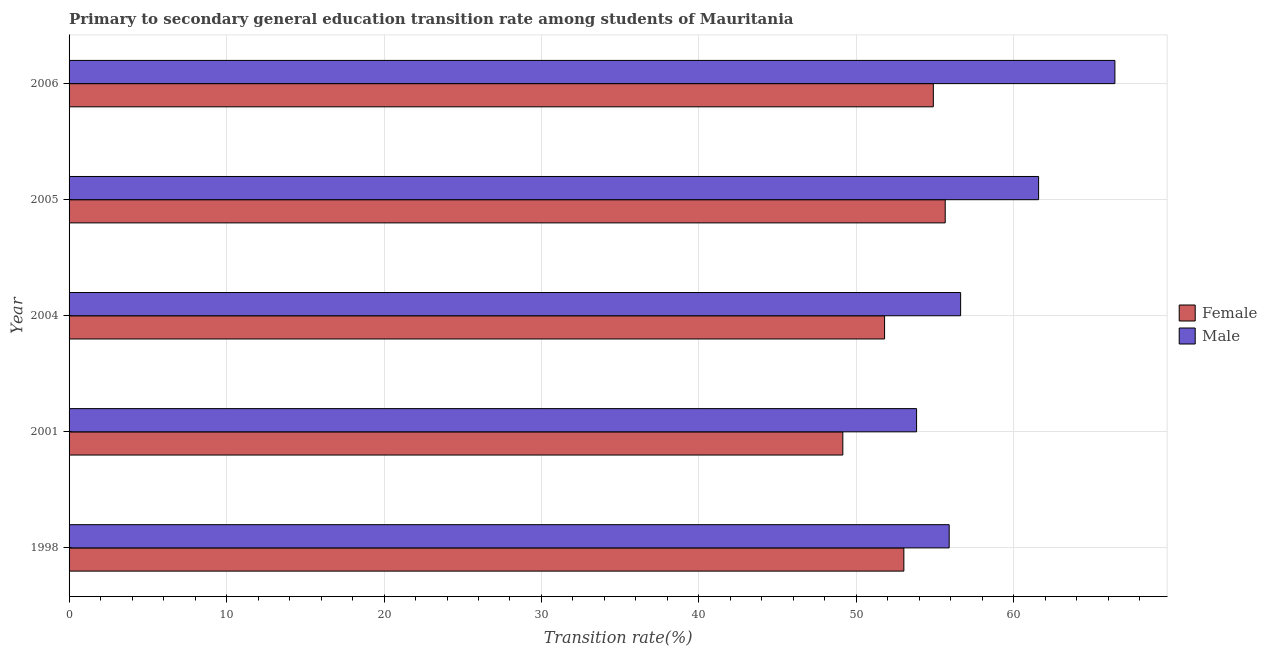How many groups of bars are there?
Keep it short and to the point. 5. Are the number of bars per tick equal to the number of legend labels?
Keep it short and to the point. Yes. Are the number of bars on each tick of the Y-axis equal?
Ensure brevity in your answer.  Yes. How many bars are there on the 4th tick from the top?
Make the answer very short. 2. In how many cases, is the number of bars for a given year not equal to the number of legend labels?
Your answer should be very brief. 0. What is the transition rate among female students in 2006?
Your answer should be very brief. 54.88. Across all years, what is the maximum transition rate among female students?
Keep it short and to the point. 55.64. Across all years, what is the minimum transition rate among male students?
Ensure brevity in your answer.  53.82. What is the total transition rate among male students in the graph?
Offer a terse response. 294.31. What is the difference between the transition rate among male students in 2005 and that in 2006?
Offer a terse response. -4.84. What is the difference between the transition rate among male students in 2006 and the transition rate among female students in 2001?
Offer a very short reply. 17.28. What is the average transition rate among male students per year?
Offer a very short reply. 58.86. In the year 2006, what is the difference between the transition rate among male students and transition rate among female students?
Your response must be concise. 11.53. In how many years, is the transition rate among female students greater than 16 %?
Offer a terse response. 5. Is the transition rate among female students in 2004 less than that in 2006?
Your response must be concise. Yes. What is the difference between the highest and the second highest transition rate among male students?
Ensure brevity in your answer.  4.84. What is the difference between the highest and the lowest transition rate among female students?
Offer a very short reply. 6.5. What does the 1st bar from the top in 2005 represents?
Your answer should be very brief. Male. How many bars are there?
Offer a terse response. 10. Are all the bars in the graph horizontal?
Your answer should be compact. Yes. Are the values on the major ticks of X-axis written in scientific E-notation?
Make the answer very short. No. Does the graph contain any zero values?
Your answer should be very brief. No. Does the graph contain grids?
Your answer should be compact. Yes. How many legend labels are there?
Offer a very short reply. 2. How are the legend labels stacked?
Provide a short and direct response. Vertical. What is the title of the graph?
Ensure brevity in your answer.  Primary to secondary general education transition rate among students of Mauritania. What is the label or title of the X-axis?
Give a very brief answer. Transition rate(%). What is the Transition rate(%) of Female in 1998?
Offer a terse response. 53.01. What is the Transition rate(%) in Male in 1998?
Your answer should be compact. 55.89. What is the Transition rate(%) in Female in 2001?
Offer a very short reply. 49.14. What is the Transition rate(%) of Male in 2001?
Offer a very short reply. 53.82. What is the Transition rate(%) in Female in 2004?
Your response must be concise. 51.79. What is the Transition rate(%) of Male in 2004?
Your answer should be very brief. 56.62. What is the Transition rate(%) of Female in 2005?
Give a very brief answer. 55.64. What is the Transition rate(%) in Male in 2005?
Offer a terse response. 61.57. What is the Transition rate(%) in Female in 2006?
Make the answer very short. 54.88. What is the Transition rate(%) of Male in 2006?
Give a very brief answer. 66.41. Across all years, what is the maximum Transition rate(%) of Female?
Ensure brevity in your answer.  55.64. Across all years, what is the maximum Transition rate(%) of Male?
Keep it short and to the point. 66.41. Across all years, what is the minimum Transition rate(%) in Female?
Provide a short and direct response. 49.14. Across all years, what is the minimum Transition rate(%) of Male?
Your answer should be compact. 53.82. What is the total Transition rate(%) of Female in the graph?
Your answer should be very brief. 264.46. What is the total Transition rate(%) in Male in the graph?
Ensure brevity in your answer.  294.31. What is the difference between the Transition rate(%) of Female in 1998 and that in 2001?
Provide a short and direct response. 3.88. What is the difference between the Transition rate(%) in Male in 1998 and that in 2001?
Offer a very short reply. 2.07. What is the difference between the Transition rate(%) of Female in 1998 and that in 2004?
Make the answer very short. 1.22. What is the difference between the Transition rate(%) of Male in 1998 and that in 2004?
Your answer should be compact. -0.73. What is the difference between the Transition rate(%) in Female in 1998 and that in 2005?
Keep it short and to the point. -2.63. What is the difference between the Transition rate(%) of Male in 1998 and that in 2005?
Provide a succinct answer. -5.68. What is the difference between the Transition rate(%) in Female in 1998 and that in 2006?
Your answer should be compact. -1.87. What is the difference between the Transition rate(%) in Male in 1998 and that in 2006?
Ensure brevity in your answer.  -10.52. What is the difference between the Transition rate(%) of Female in 2001 and that in 2004?
Offer a very short reply. -2.65. What is the difference between the Transition rate(%) in Male in 2001 and that in 2004?
Make the answer very short. -2.8. What is the difference between the Transition rate(%) of Female in 2001 and that in 2005?
Your response must be concise. -6.5. What is the difference between the Transition rate(%) of Male in 2001 and that in 2005?
Your answer should be compact. -7.75. What is the difference between the Transition rate(%) of Female in 2001 and that in 2006?
Give a very brief answer. -5.75. What is the difference between the Transition rate(%) in Male in 2001 and that in 2006?
Provide a short and direct response. -12.59. What is the difference between the Transition rate(%) in Female in 2004 and that in 2005?
Provide a short and direct response. -3.85. What is the difference between the Transition rate(%) in Male in 2004 and that in 2005?
Your answer should be compact. -4.95. What is the difference between the Transition rate(%) in Female in 2004 and that in 2006?
Make the answer very short. -3.1. What is the difference between the Transition rate(%) in Male in 2004 and that in 2006?
Your response must be concise. -9.8. What is the difference between the Transition rate(%) in Female in 2005 and that in 2006?
Provide a short and direct response. 0.76. What is the difference between the Transition rate(%) in Male in 2005 and that in 2006?
Offer a very short reply. -4.85. What is the difference between the Transition rate(%) in Female in 1998 and the Transition rate(%) in Male in 2001?
Your answer should be compact. -0.81. What is the difference between the Transition rate(%) in Female in 1998 and the Transition rate(%) in Male in 2004?
Keep it short and to the point. -3.6. What is the difference between the Transition rate(%) of Female in 1998 and the Transition rate(%) of Male in 2005?
Keep it short and to the point. -8.56. What is the difference between the Transition rate(%) in Female in 1998 and the Transition rate(%) in Male in 2006?
Your answer should be compact. -13.4. What is the difference between the Transition rate(%) in Female in 2001 and the Transition rate(%) in Male in 2004?
Give a very brief answer. -7.48. What is the difference between the Transition rate(%) of Female in 2001 and the Transition rate(%) of Male in 2005?
Keep it short and to the point. -12.43. What is the difference between the Transition rate(%) of Female in 2001 and the Transition rate(%) of Male in 2006?
Your answer should be very brief. -17.28. What is the difference between the Transition rate(%) of Female in 2004 and the Transition rate(%) of Male in 2005?
Ensure brevity in your answer.  -9.78. What is the difference between the Transition rate(%) of Female in 2004 and the Transition rate(%) of Male in 2006?
Your answer should be compact. -14.63. What is the difference between the Transition rate(%) in Female in 2005 and the Transition rate(%) in Male in 2006?
Provide a succinct answer. -10.78. What is the average Transition rate(%) of Female per year?
Offer a terse response. 52.89. What is the average Transition rate(%) in Male per year?
Give a very brief answer. 58.86. In the year 1998, what is the difference between the Transition rate(%) of Female and Transition rate(%) of Male?
Your answer should be very brief. -2.88. In the year 2001, what is the difference between the Transition rate(%) in Female and Transition rate(%) in Male?
Your response must be concise. -4.68. In the year 2004, what is the difference between the Transition rate(%) in Female and Transition rate(%) in Male?
Your response must be concise. -4.83. In the year 2005, what is the difference between the Transition rate(%) of Female and Transition rate(%) of Male?
Give a very brief answer. -5.93. In the year 2006, what is the difference between the Transition rate(%) in Female and Transition rate(%) in Male?
Your answer should be compact. -11.53. What is the ratio of the Transition rate(%) in Female in 1998 to that in 2001?
Keep it short and to the point. 1.08. What is the ratio of the Transition rate(%) in Female in 1998 to that in 2004?
Keep it short and to the point. 1.02. What is the ratio of the Transition rate(%) in Male in 1998 to that in 2004?
Give a very brief answer. 0.99. What is the ratio of the Transition rate(%) in Female in 1998 to that in 2005?
Offer a terse response. 0.95. What is the ratio of the Transition rate(%) in Male in 1998 to that in 2005?
Your answer should be compact. 0.91. What is the ratio of the Transition rate(%) of Female in 1998 to that in 2006?
Make the answer very short. 0.97. What is the ratio of the Transition rate(%) in Male in 1998 to that in 2006?
Provide a succinct answer. 0.84. What is the ratio of the Transition rate(%) in Female in 2001 to that in 2004?
Offer a terse response. 0.95. What is the ratio of the Transition rate(%) in Male in 2001 to that in 2004?
Your response must be concise. 0.95. What is the ratio of the Transition rate(%) of Female in 2001 to that in 2005?
Provide a succinct answer. 0.88. What is the ratio of the Transition rate(%) of Male in 2001 to that in 2005?
Your answer should be very brief. 0.87. What is the ratio of the Transition rate(%) of Female in 2001 to that in 2006?
Provide a short and direct response. 0.9. What is the ratio of the Transition rate(%) in Male in 2001 to that in 2006?
Provide a short and direct response. 0.81. What is the ratio of the Transition rate(%) in Female in 2004 to that in 2005?
Provide a succinct answer. 0.93. What is the ratio of the Transition rate(%) of Male in 2004 to that in 2005?
Offer a very short reply. 0.92. What is the ratio of the Transition rate(%) in Female in 2004 to that in 2006?
Provide a short and direct response. 0.94. What is the ratio of the Transition rate(%) in Male in 2004 to that in 2006?
Provide a succinct answer. 0.85. What is the ratio of the Transition rate(%) of Female in 2005 to that in 2006?
Offer a terse response. 1.01. What is the ratio of the Transition rate(%) of Male in 2005 to that in 2006?
Provide a short and direct response. 0.93. What is the difference between the highest and the second highest Transition rate(%) of Female?
Your answer should be compact. 0.76. What is the difference between the highest and the second highest Transition rate(%) in Male?
Your answer should be very brief. 4.85. What is the difference between the highest and the lowest Transition rate(%) of Female?
Your answer should be compact. 6.5. What is the difference between the highest and the lowest Transition rate(%) of Male?
Offer a very short reply. 12.59. 